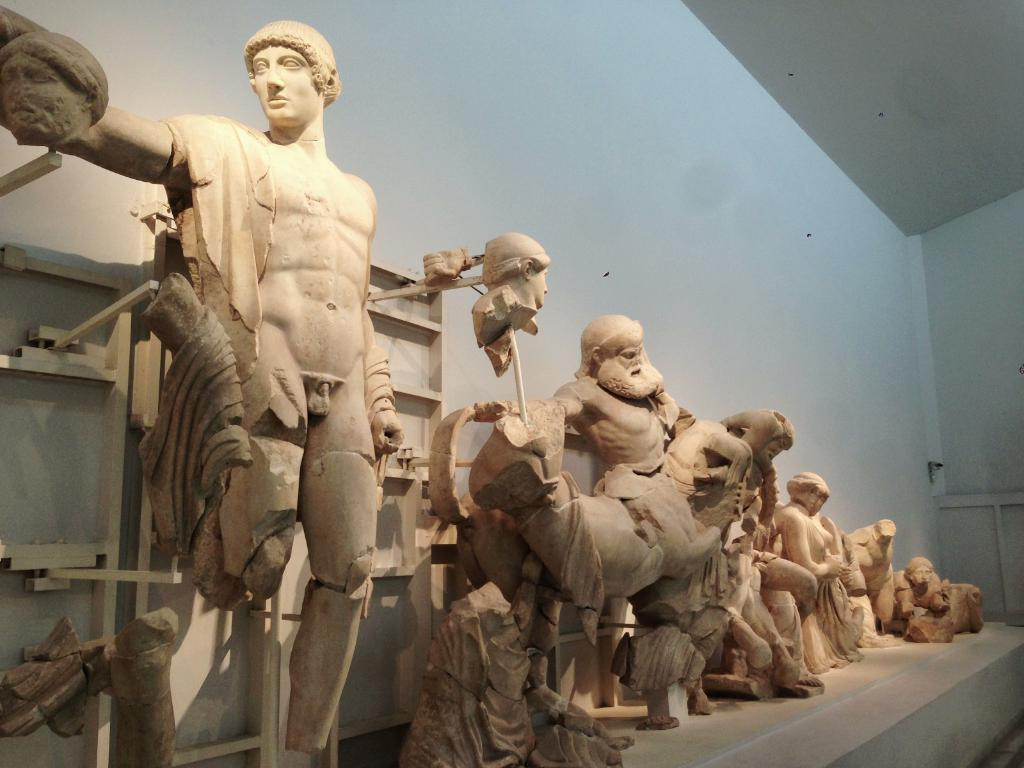What type of art is present in the image? There are sculptures in the image. What can be seen in the background of the image? There is a wall in the background of the image. Are there any bears flying in the image? No, there are no bears or any indication of flight present in the image. 